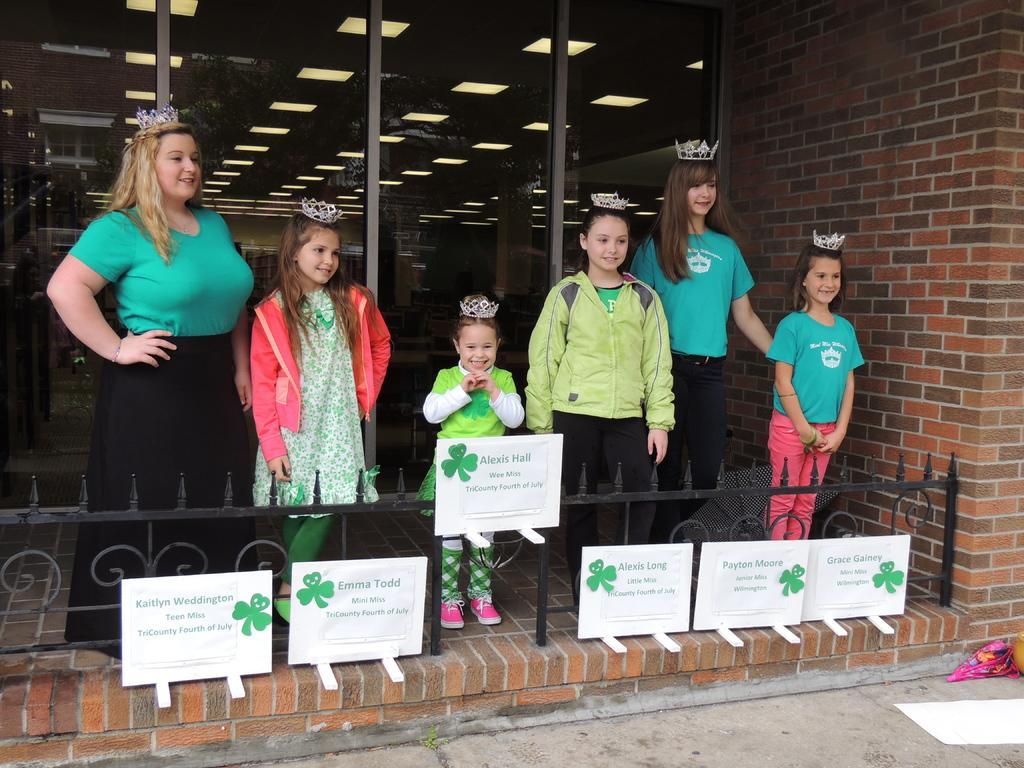Could you give a brief overview of what you see in this image? In this image I can see the group of people with different color dresses and these people are wearing the crowns. In-front of these people I can see the railing and the boards. To the right I can see the brick wall. In the background I can see the lights at the top. 